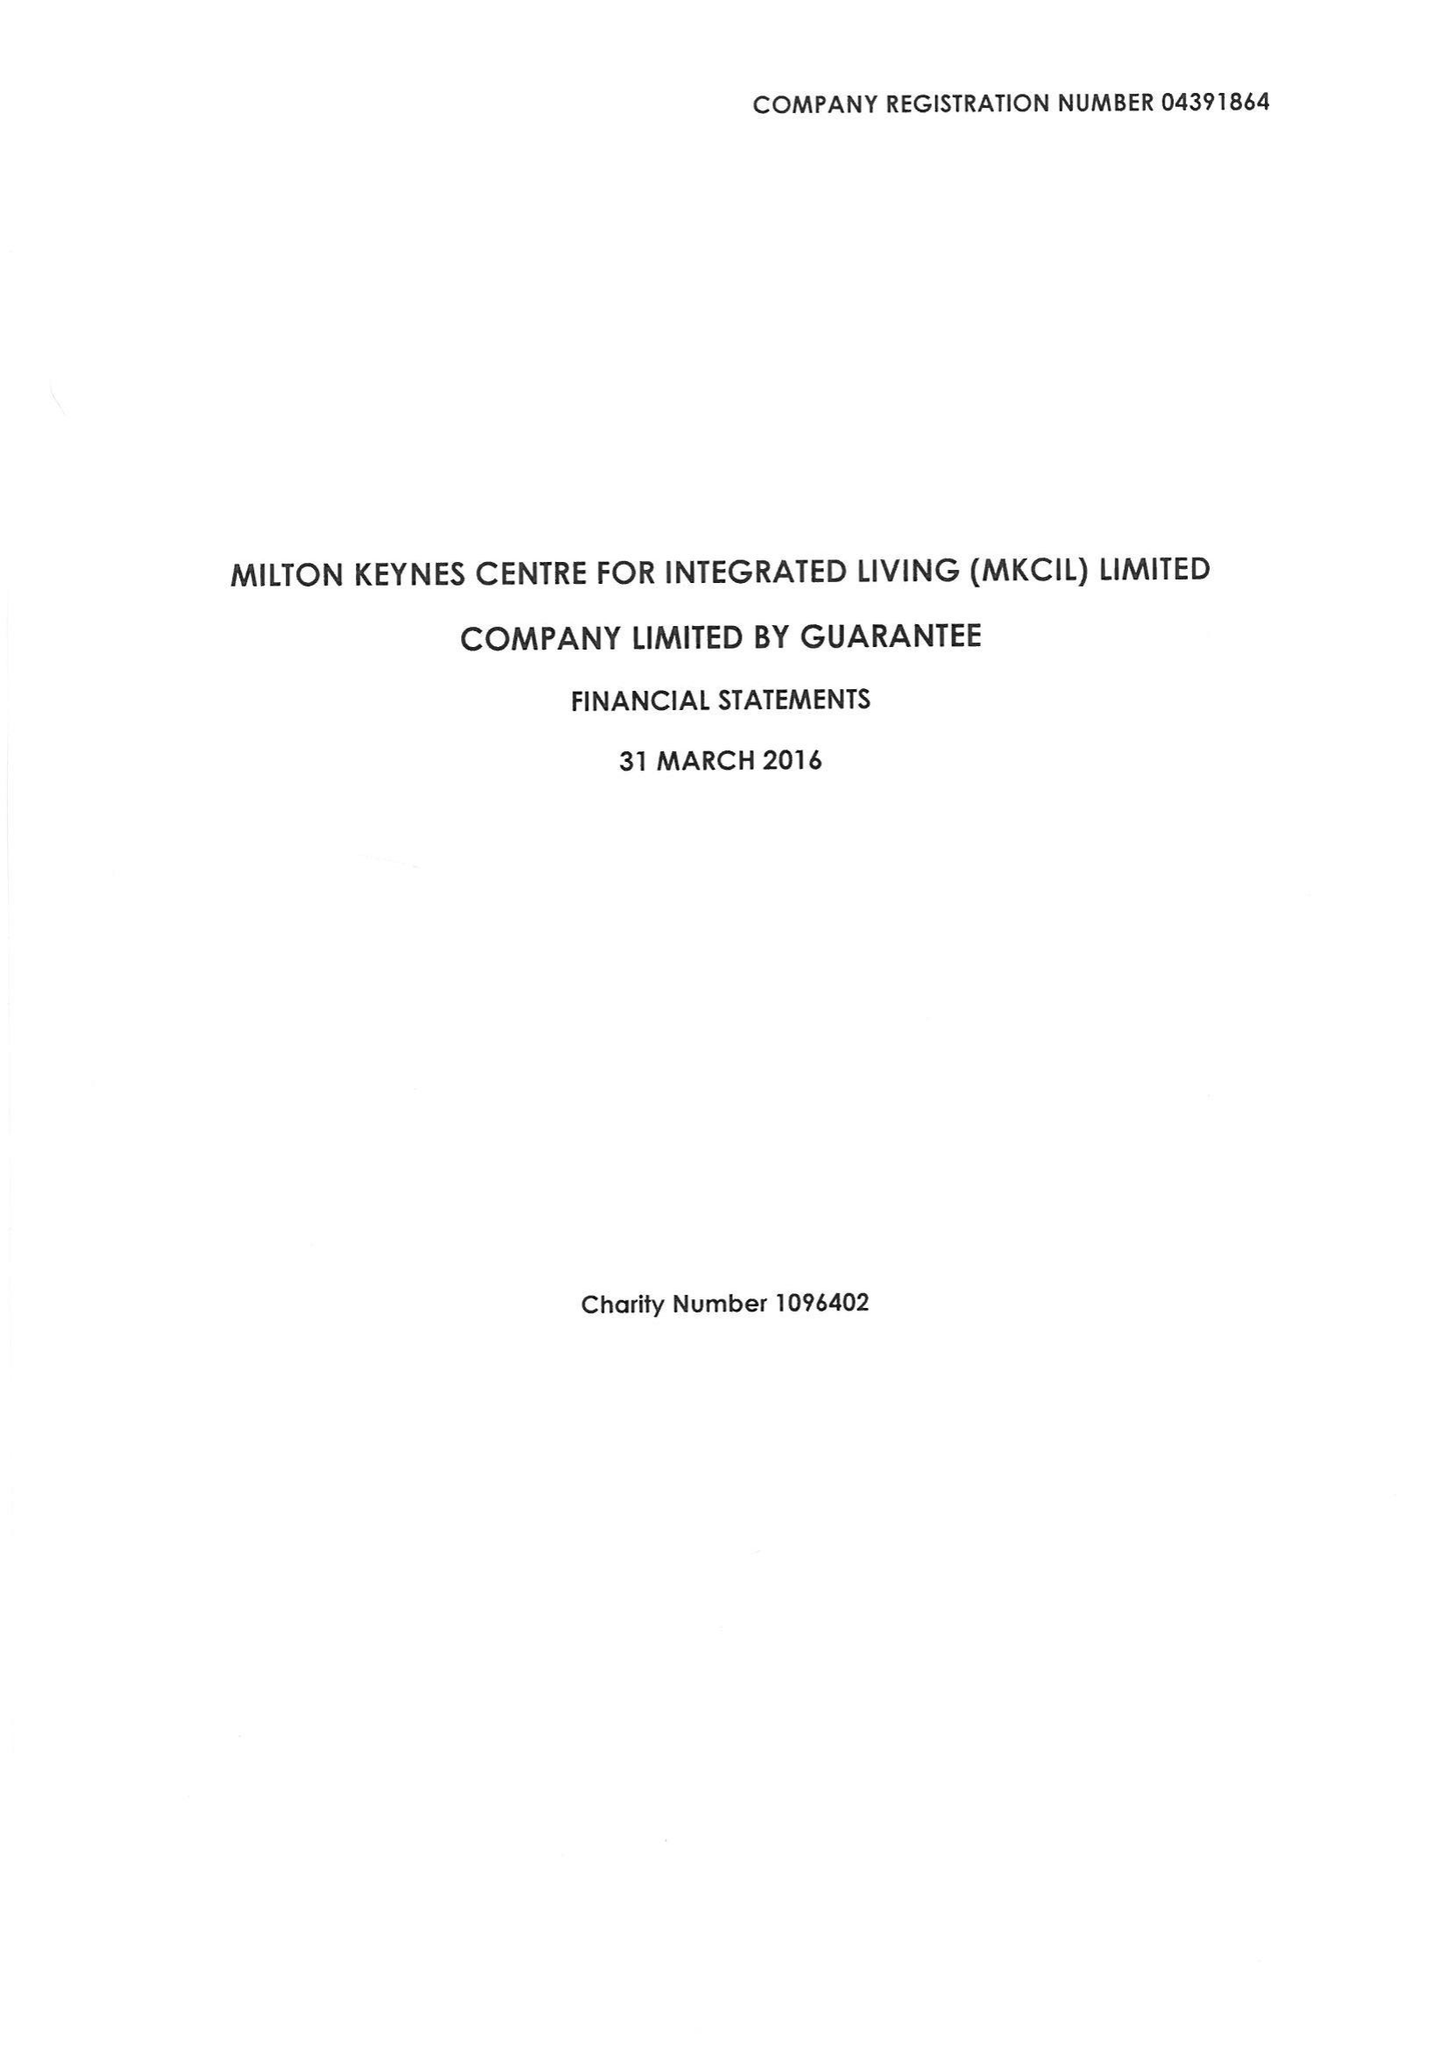What is the value for the address__postcode?
Answer the question using a single word or phrase. MK6 2QW 